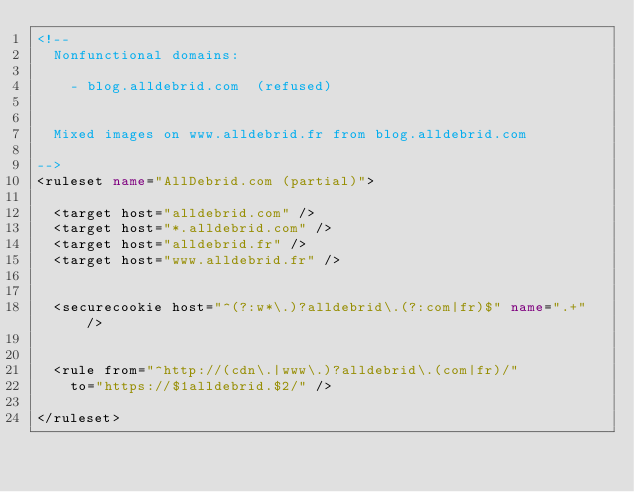Convert code to text. <code><loc_0><loc_0><loc_500><loc_500><_XML_><!--
	Nonfunctional domains:

		- blog.alldebrid.com	(refused)


	Mixed images on www.alldebrid.fr from blog.alldebrid.com

-->
<ruleset name="AllDebrid.com (partial)">

	<target host="alldebrid.com" />
	<target host="*.alldebrid.com" />
	<target host="alldebrid.fr" />
	<target host="www.alldebrid.fr" />


	<securecookie host="^(?:w*\.)?alldebrid\.(?:com|fr)$" name=".+" />


	<rule from="^http://(cdn\.|www\.)?alldebrid\.(com|fr)/"
		to="https://$1alldebrid.$2/" />

</ruleset></code> 